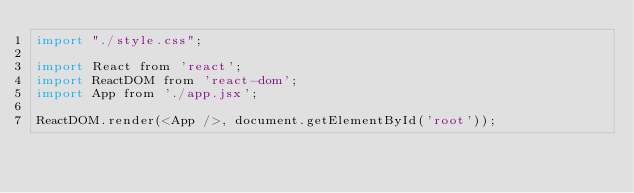<code> <loc_0><loc_0><loc_500><loc_500><_JavaScript_>import "./style.css";

import React from 'react';
import ReactDOM from 'react-dom';
import App from './app.jsx';

ReactDOM.render(<App />, document.getElementById('root'));
</code> 